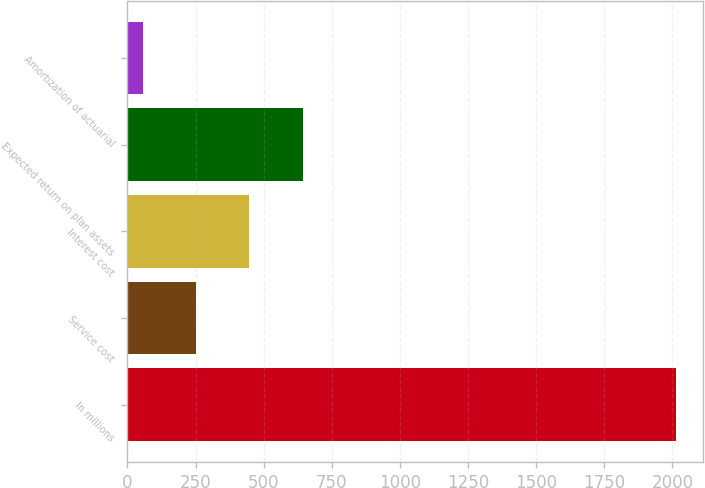Convert chart. <chart><loc_0><loc_0><loc_500><loc_500><bar_chart><fcel>In millions<fcel>Service cost<fcel>Interest cost<fcel>Expected return on plan assets<fcel>Amortization of actuarial<nl><fcel>2012<fcel>252.5<fcel>448<fcel>643.5<fcel>57<nl></chart> 